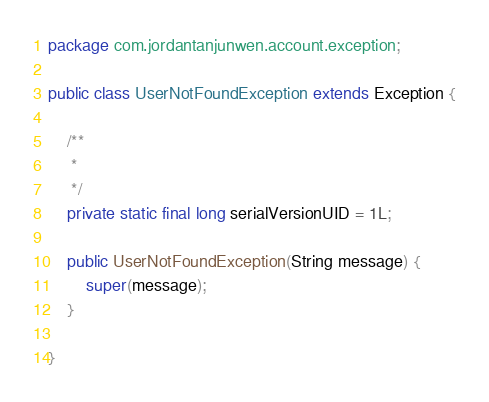Convert code to text. <code><loc_0><loc_0><loc_500><loc_500><_Java_>package com.jordantanjunwen.account.exception;

public class UserNotFoundException extends Exception {

	/**
	 * 
	 */
	private static final long serialVersionUID = 1L;
	
	public UserNotFoundException(String message) {
		super(message);
	}

}
</code> 